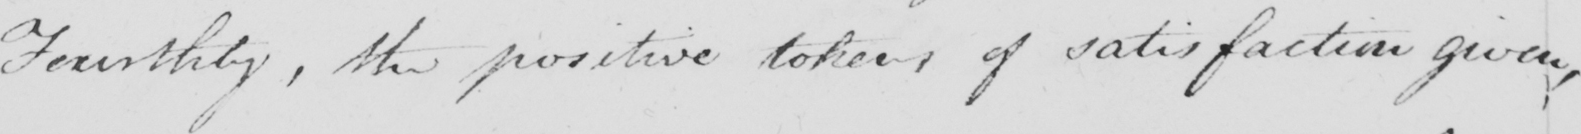Can you tell me what this handwritten text says? Fourthly , the positive tokens of satisfaction given , 